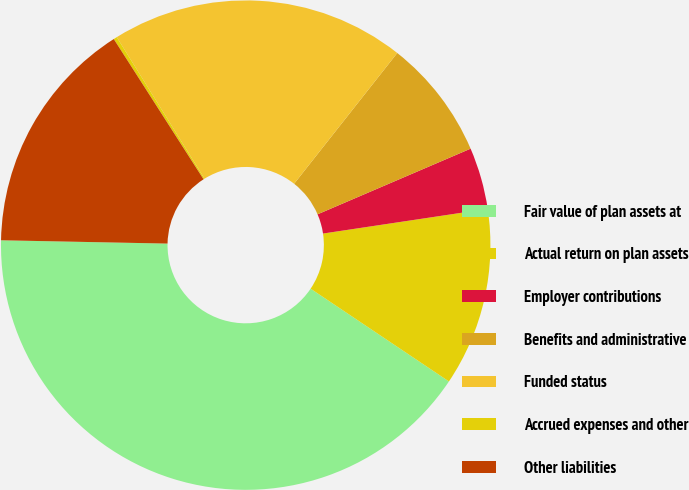<chart> <loc_0><loc_0><loc_500><loc_500><pie_chart><fcel>Fair value of plan assets at<fcel>Actual return on plan assets<fcel>Employer contributions<fcel>Benefits and administrative<fcel>Funded status<fcel>Accrued expenses and other<fcel>Other liabilities<nl><fcel>40.91%<fcel>11.77%<fcel>4.08%<fcel>7.92%<fcel>19.46%<fcel>0.23%<fcel>15.62%<nl></chart> 